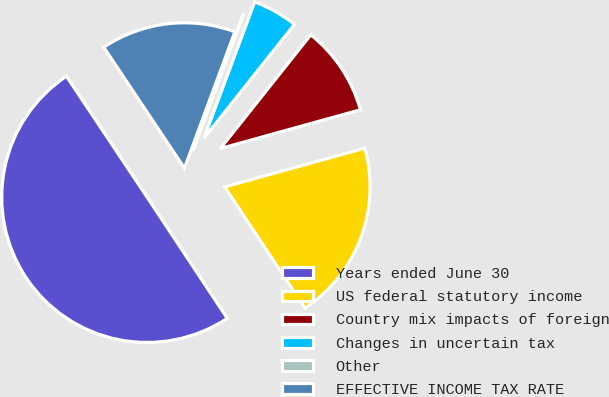Convert chart to OTSL. <chart><loc_0><loc_0><loc_500><loc_500><pie_chart><fcel>Years ended June 30<fcel>US federal statutory income<fcel>Country mix impacts of foreign<fcel>Changes in uncertain tax<fcel>Other<fcel>EFFECTIVE INCOME TAX RATE<nl><fcel>49.93%<fcel>19.99%<fcel>10.01%<fcel>5.02%<fcel>0.03%<fcel>15.0%<nl></chart> 